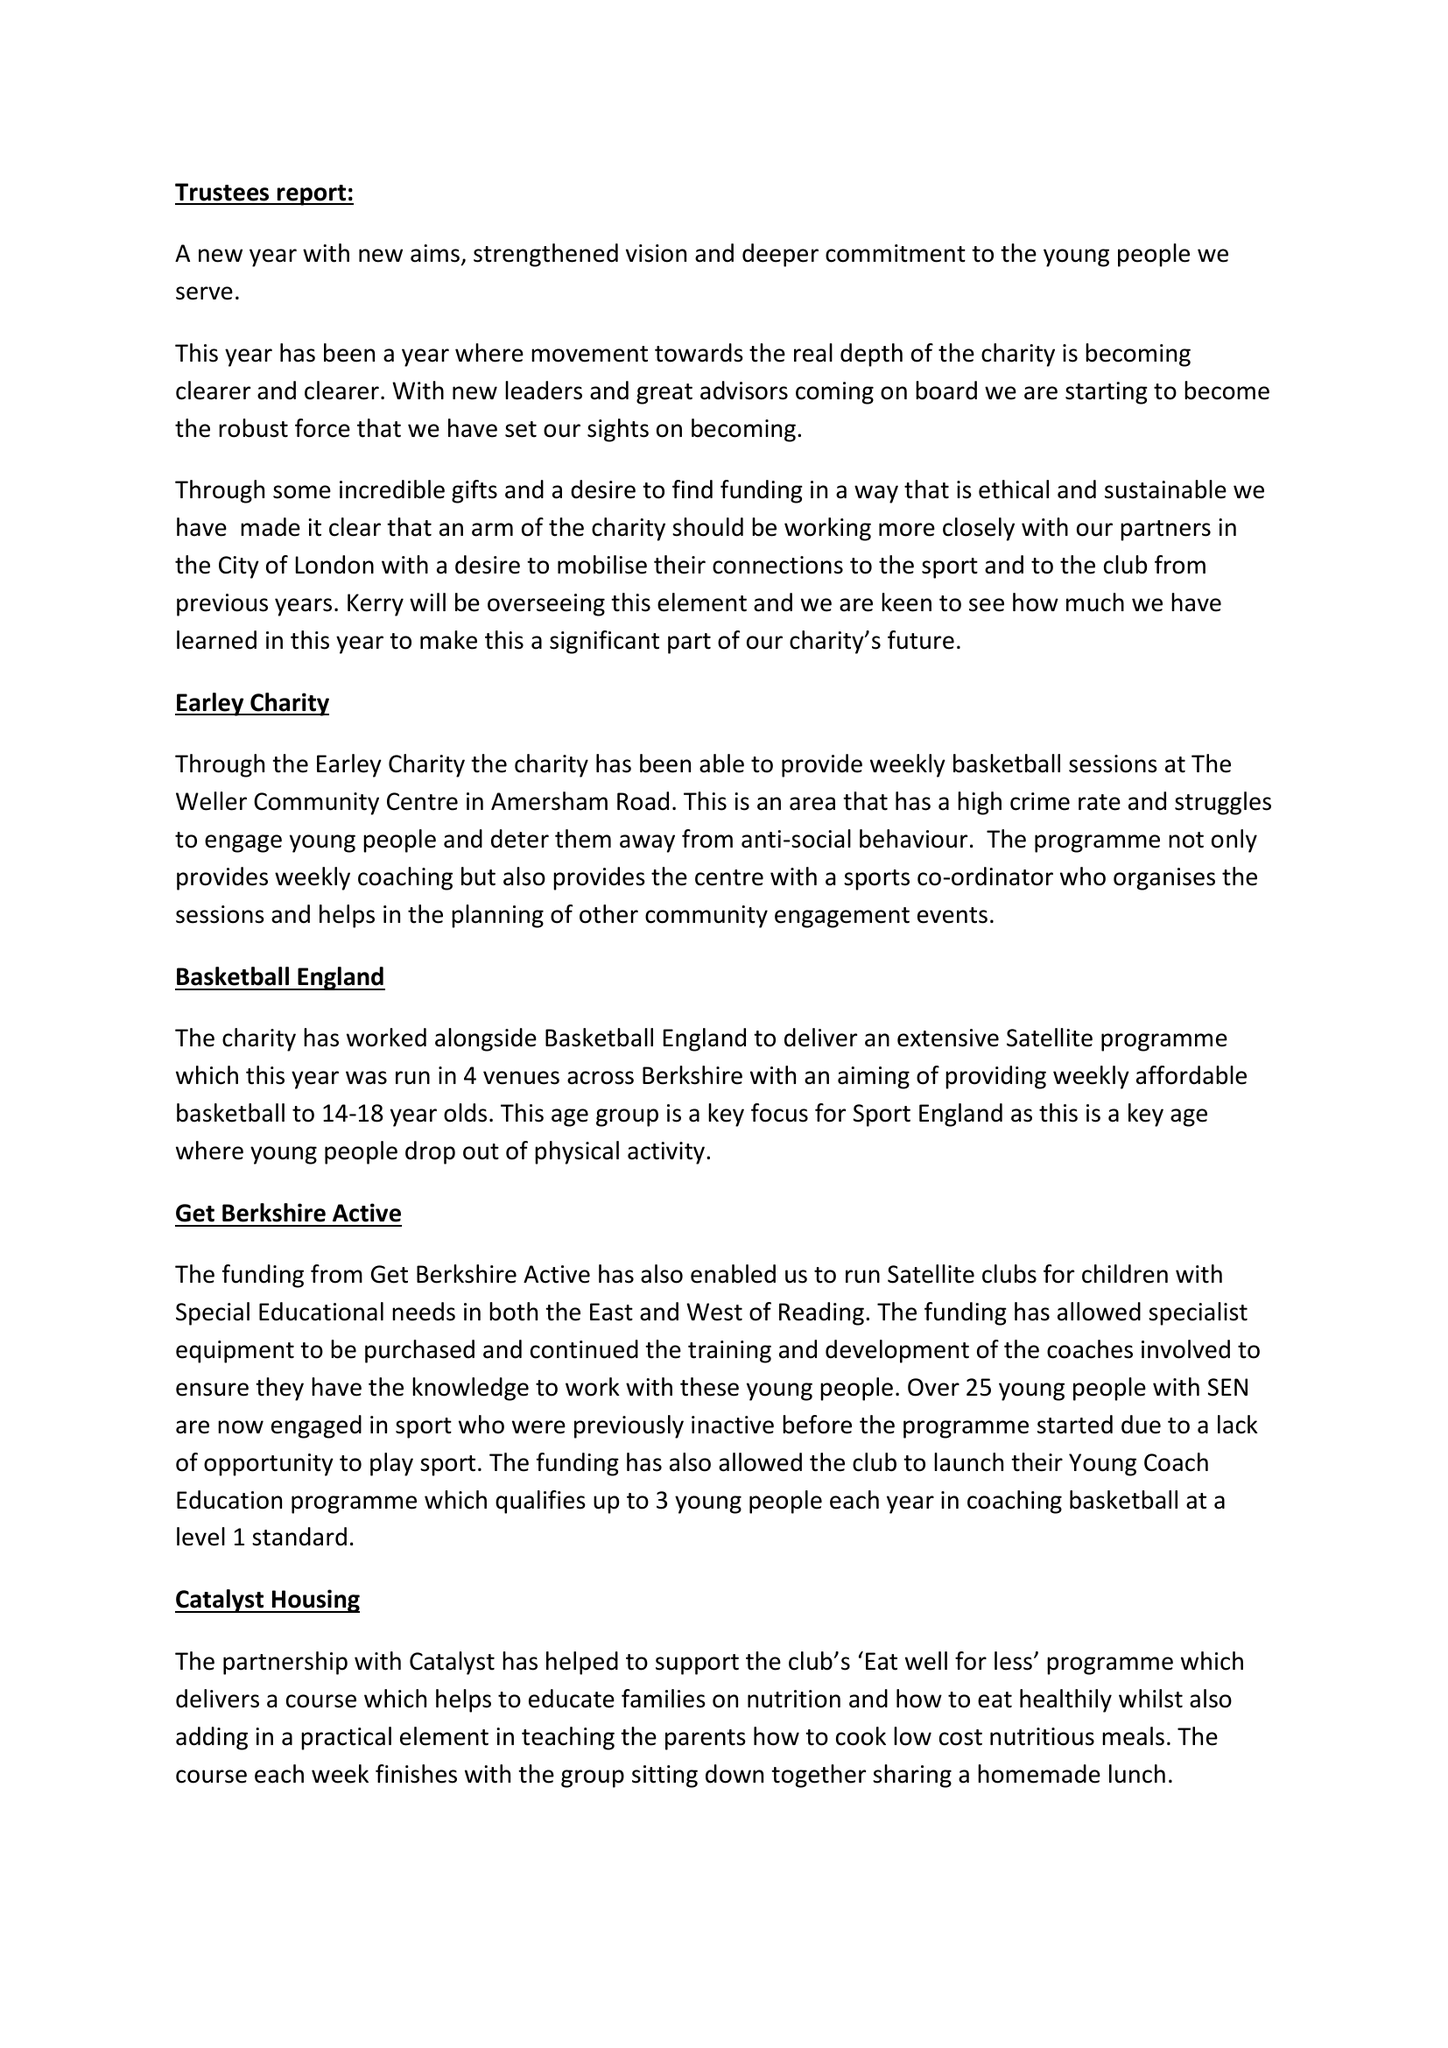What is the value for the spending_annually_in_british_pounds?
Answer the question using a single word or phrase. 29713.00 